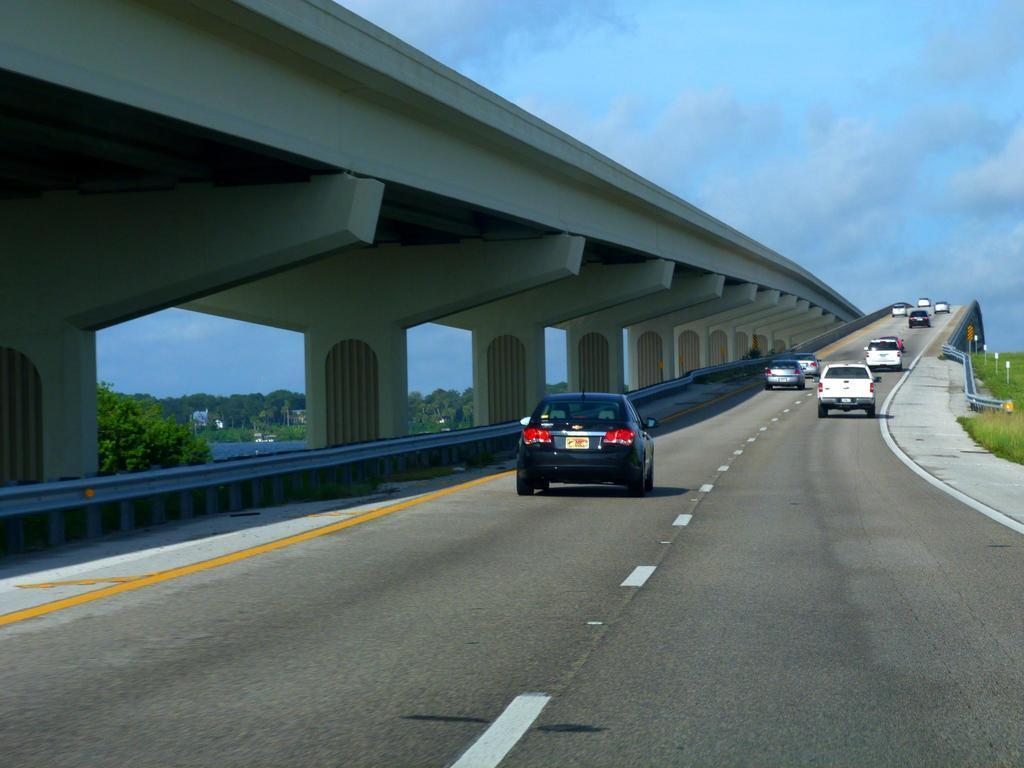Describe this image in one or two sentences. In the image we can see there are many vehicles on the road. Here we can see the bridge, trees, poles and the cloudy sky. 